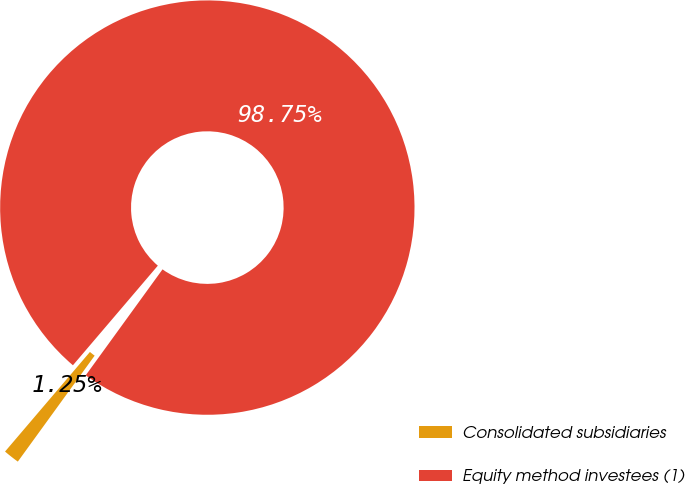<chart> <loc_0><loc_0><loc_500><loc_500><pie_chart><fcel>Consolidated subsidiaries<fcel>Equity method investees (1)<nl><fcel>1.25%<fcel>98.75%<nl></chart> 